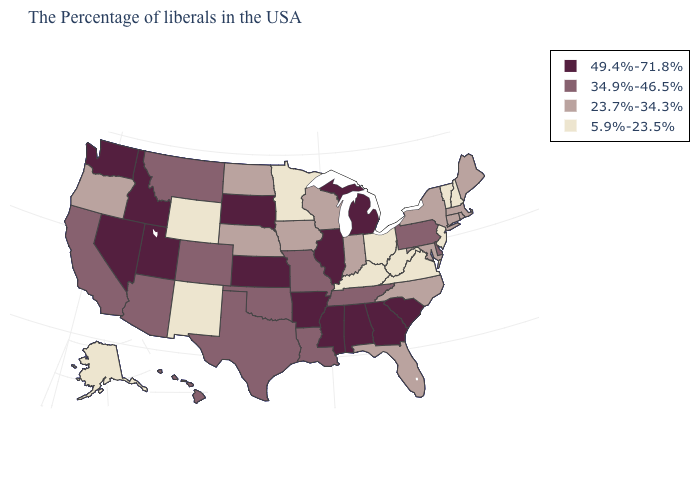What is the highest value in the South ?
Quick response, please. 49.4%-71.8%. What is the value of South Carolina?
Short answer required. 49.4%-71.8%. What is the value of Nevada?
Short answer required. 49.4%-71.8%. Name the states that have a value in the range 23.7%-34.3%?
Give a very brief answer. Maine, Massachusetts, Rhode Island, Connecticut, New York, Maryland, North Carolina, Florida, Indiana, Wisconsin, Iowa, Nebraska, North Dakota, Oregon. Name the states that have a value in the range 5.9%-23.5%?
Quick response, please. New Hampshire, Vermont, New Jersey, Virginia, West Virginia, Ohio, Kentucky, Minnesota, Wyoming, New Mexico, Alaska. Does Minnesota have the same value as Wyoming?
Give a very brief answer. Yes. Among the states that border Massachusetts , does New York have the highest value?
Short answer required. Yes. Does Wyoming have the lowest value in the West?
Concise answer only. Yes. Which states have the highest value in the USA?
Quick response, please. South Carolina, Georgia, Michigan, Alabama, Illinois, Mississippi, Arkansas, Kansas, South Dakota, Utah, Idaho, Nevada, Washington. Which states have the lowest value in the USA?
Be succinct. New Hampshire, Vermont, New Jersey, Virginia, West Virginia, Ohio, Kentucky, Minnesota, Wyoming, New Mexico, Alaska. Which states hav the highest value in the Northeast?
Quick response, please. Pennsylvania. Among the states that border Tennessee , does Virginia have the lowest value?
Quick response, please. Yes. Does Connecticut have the lowest value in the Northeast?
Answer briefly. No. What is the value of Illinois?
Give a very brief answer. 49.4%-71.8%. What is the value of Wyoming?
Be succinct. 5.9%-23.5%. 